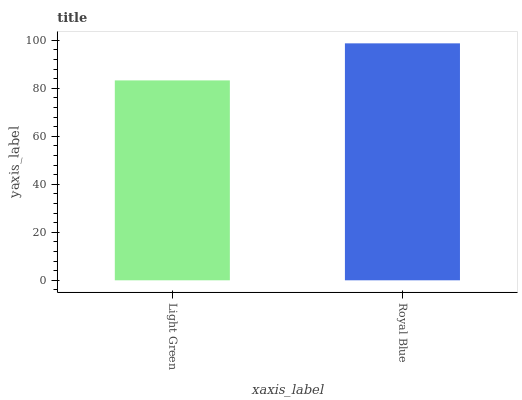Is Royal Blue the minimum?
Answer yes or no. No. Is Royal Blue greater than Light Green?
Answer yes or no. Yes. Is Light Green less than Royal Blue?
Answer yes or no. Yes. Is Light Green greater than Royal Blue?
Answer yes or no. No. Is Royal Blue less than Light Green?
Answer yes or no. No. Is Royal Blue the high median?
Answer yes or no. Yes. Is Light Green the low median?
Answer yes or no. Yes. Is Light Green the high median?
Answer yes or no. No. Is Royal Blue the low median?
Answer yes or no. No. 